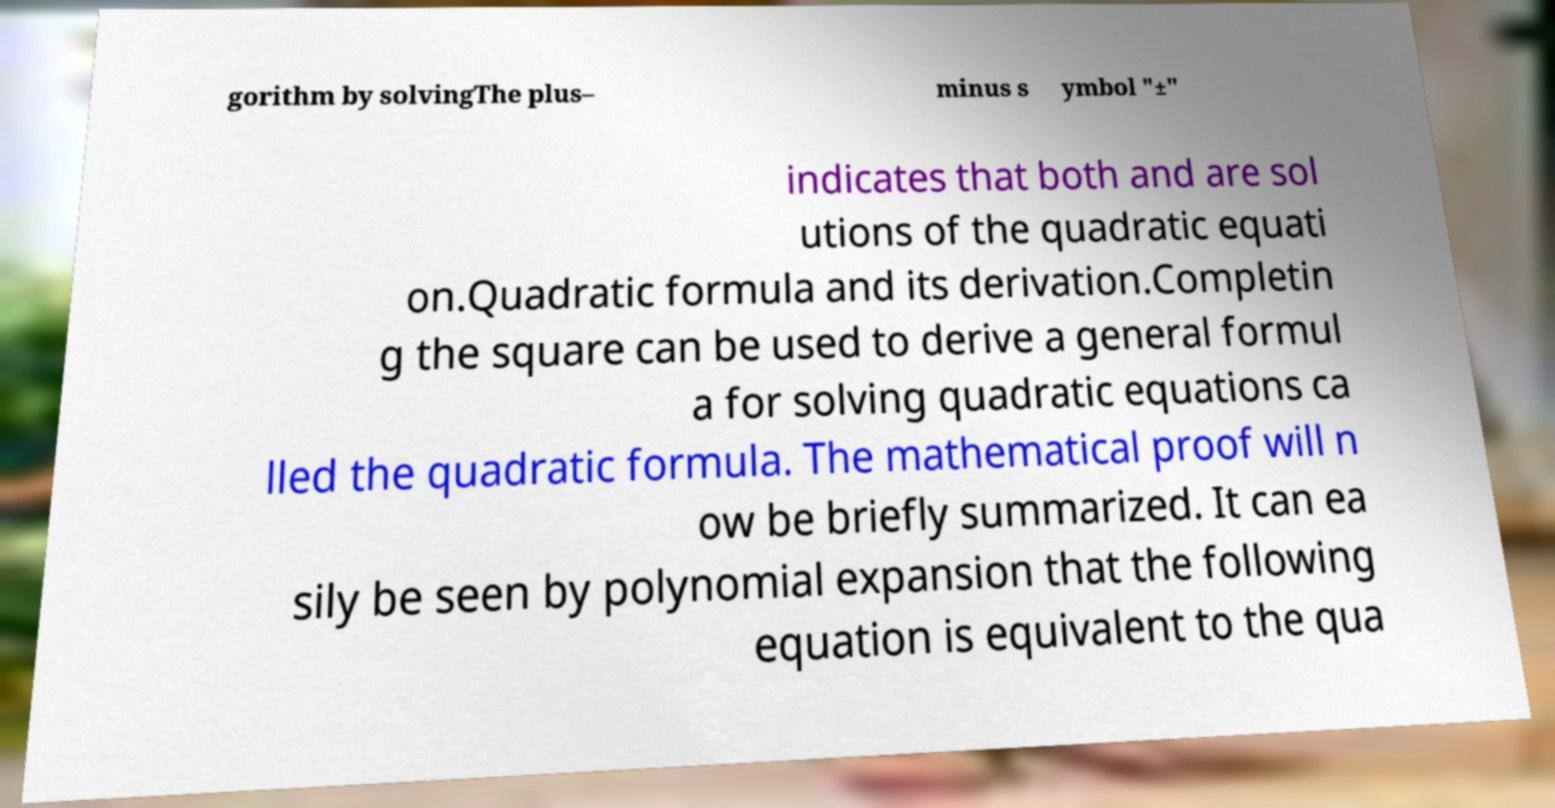Please read and relay the text visible in this image. What does it say? gorithm by solvingThe plus– minus s ymbol "±" indicates that both and are sol utions of the quadratic equati on.Quadratic formula and its derivation.Completin g the square can be used to derive a general formul a for solving quadratic equations ca lled the quadratic formula. The mathematical proof will n ow be briefly summarized. It can ea sily be seen by polynomial expansion that the following equation is equivalent to the qua 